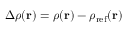Convert formula to latex. <formula><loc_0><loc_0><loc_500><loc_500>\Delta \rho ( { r } ) = \rho ( { r } ) - \rho _ { r e f } ( { r } )</formula> 